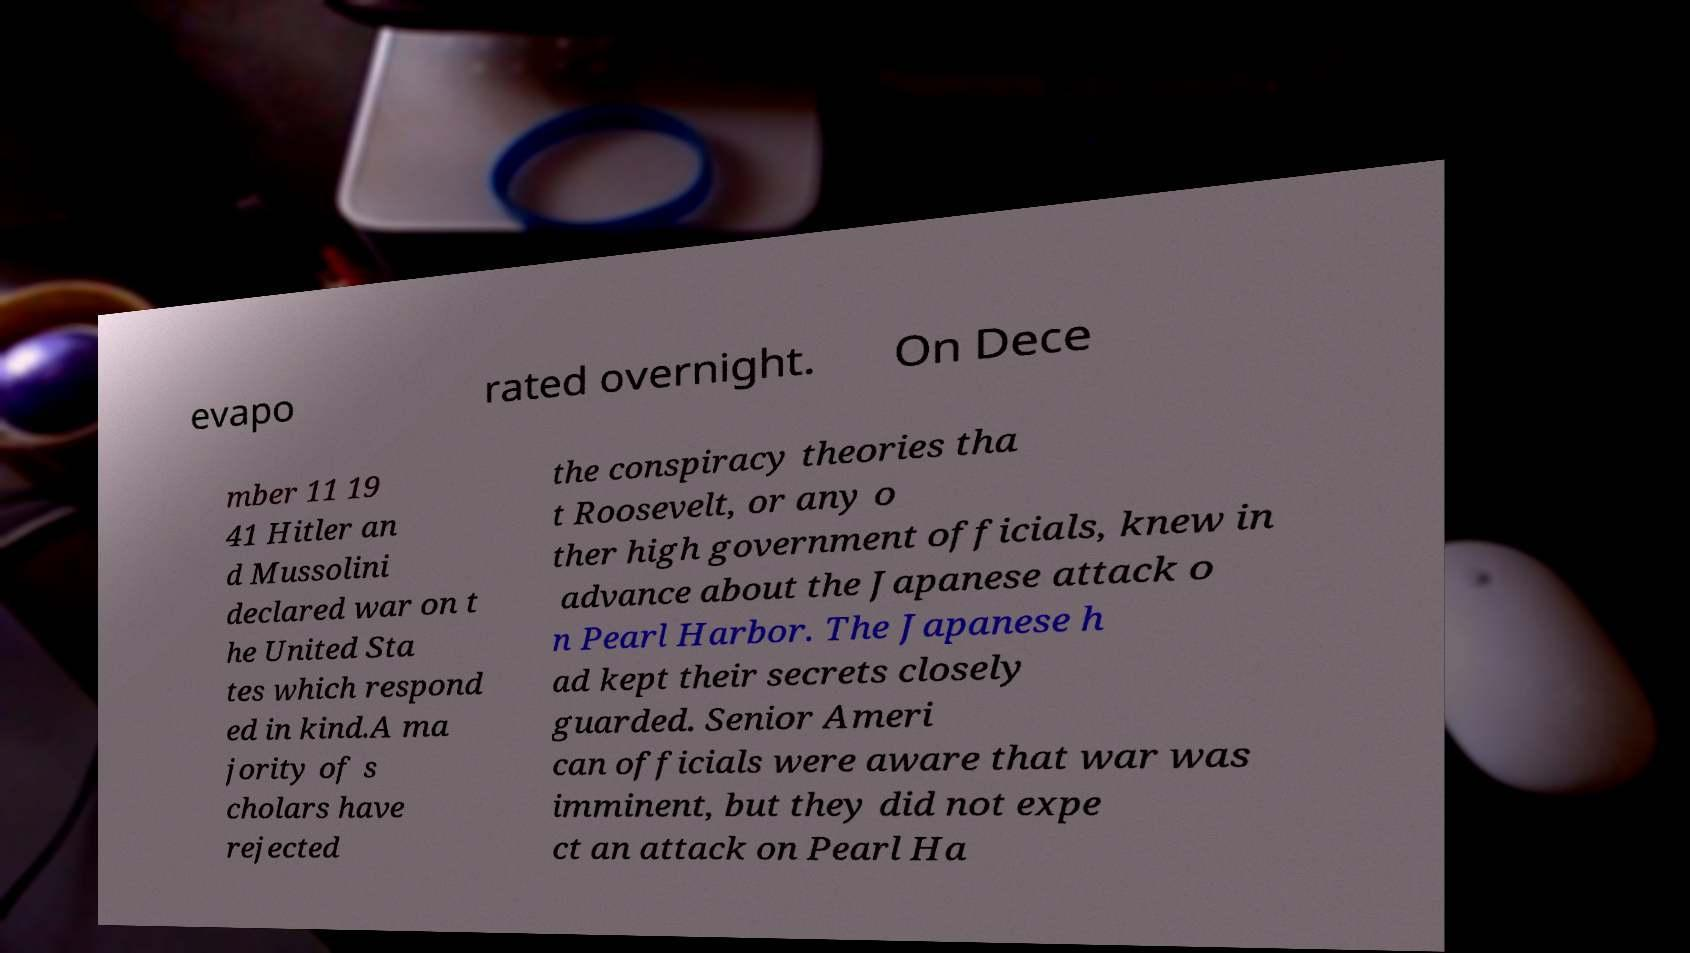For documentation purposes, I need the text within this image transcribed. Could you provide that? evapo rated overnight. On Dece mber 11 19 41 Hitler an d Mussolini declared war on t he United Sta tes which respond ed in kind.A ma jority of s cholars have rejected the conspiracy theories tha t Roosevelt, or any o ther high government officials, knew in advance about the Japanese attack o n Pearl Harbor. The Japanese h ad kept their secrets closely guarded. Senior Ameri can officials were aware that war was imminent, but they did not expe ct an attack on Pearl Ha 